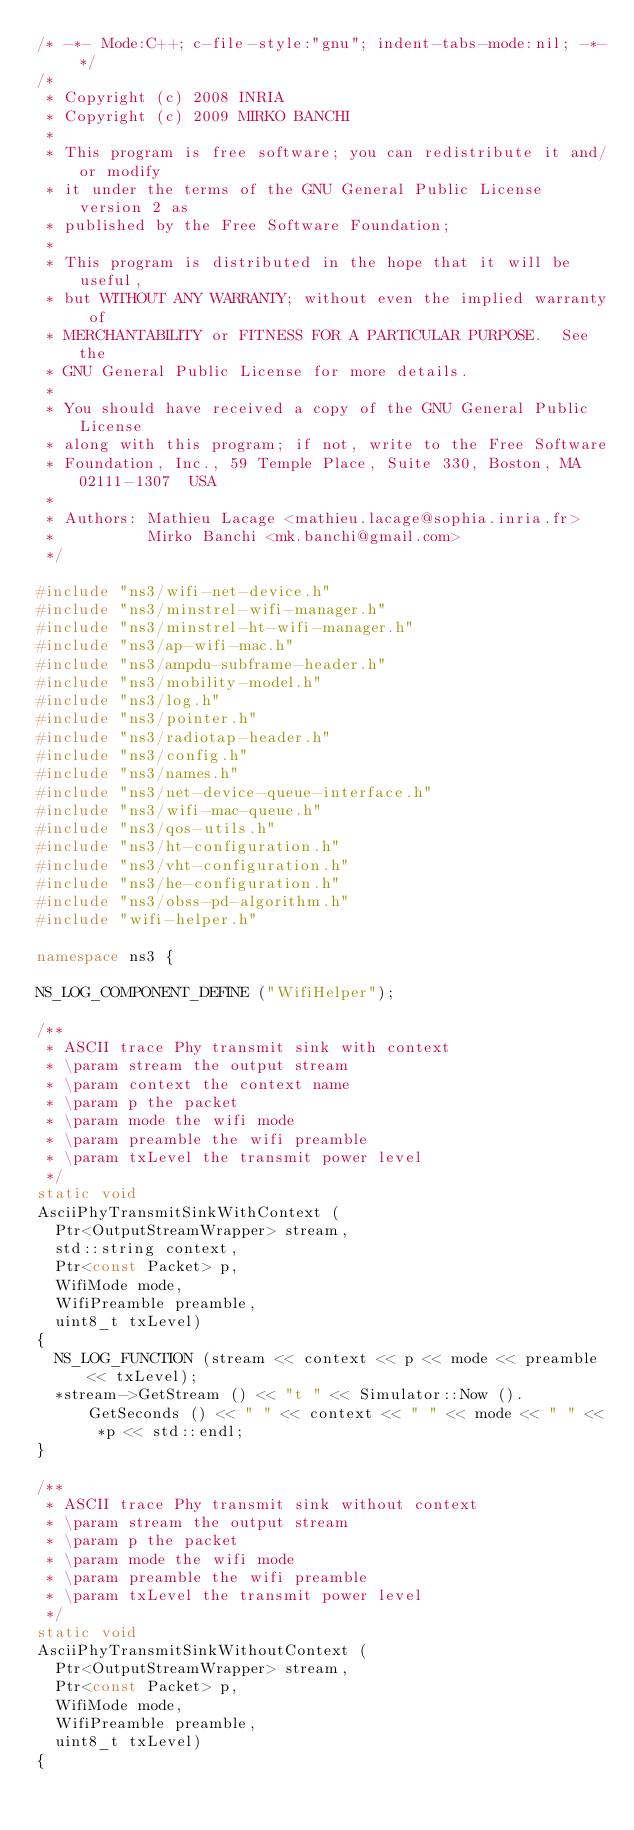Convert code to text. <code><loc_0><loc_0><loc_500><loc_500><_C++_>/* -*- Mode:C++; c-file-style:"gnu"; indent-tabs-mode:nil; -*- */
/*
 * Copyright (c) 2008 INRIA
 * Copyright (c) 2009 MIRKO BANCHI
 *
 * This program is free software; you can redistribute it and/or modify
 * it under the terms of the GNU General Public License version 2 as
 * published by the Free Software Foundation;
 *
 * This program is distributed in the hope that it will be useful,
 * but WITHOUT ANY WARRANTY; without even the implied warranty of
 * MERCHANTABILITY or FITNESS FOR A PARTICULAR PURPOSE.  See the
 * GNU General Public License for more details.
 *
 * You should have received a copy of the GNU General Public License
 * along with this program; if not, write to the Free Software
 * Foundation, Inc., 59 Temple Place, Suite 330, Boston, MA  02111-1307  USA
 *
 * Authors: Mathieu Lacage <mathieu.lacage@sophia.inria.fr>
 *          Mirko Banchi <mk.banchi@gmail.com>
 */

#include "ns3/wifi-net-device.h"
#include "ns3/minstrel-wifi-manager.h"
#include "ns3/minstrel-ht-wifi-manager.h"
#include "ns3/ap-wifi-mac.h"
#include "ns3/ampdu-subframe-header.h"
#include "ns3/mobility-model.h"
#include "ns3/log.h"
#include "ns3/pointer.h"
#include "ns3/radiotap-header.h"
#include "ns3/config.h"
#include "ns3/names.h"
#include "ns3/net-device-queue-interface.h"
#include "ns3/wifi-mac-queue.h"
#include "ns3/qos-utils.h"
#include "ns3/ht-configuration.h"
#include "ns3/vht-configuration.h"
#include "ns3/he-configuration.h"
#include "ns3/obss-pd-algorithm.h"
#include "wifi-helper.h"

namespace ns3 {

NS_LOG_COMPONENT_DEFINE ("WifiHelper");

/**
 * ASCII trace Phy transmit sink with context
 * \param stream the output stream
 * \param context the context name
 * \param p the packet
 * \param mode the wifi mode
 * \param preamble the wifi preamble
 * \param txLevel the transmit power level
 */
static void
AsciiPhyTransmitSinkWithContext (
  Ptr<OutputStreamWrapper> stream,
  std::string context,
  Ptr<const Packet> p,
  WifiMode mode,
  WifiPreamble preamble,
  uint8_t txLevel)
{
  NS_LOG_FUNCTION (stream << context << p << mode << preamble << txLevel);
  *stream->GetStream () << "t " << Simulator::Now ().GetSeconds () << " " << context << " " << mode << " " << *p << std::endl;
}

/**
 * ASCII trace Phy transmit sink without context
 * \param stream the output stream
 * \param p the packet
 * \param mode the wifi mode
 * \param preamble the wifi preamble
 * \param txLevel the transmit power level
 */
static void
AsciiPhyTransmitSinkWithoutContext (
  Ptr<OutputStreamWrapper> stream,
  Ptr<const Packet> p,
  WifiMode mode,
  WifiPreamble preamble,
  uint8_t txLevel)
{</code> 